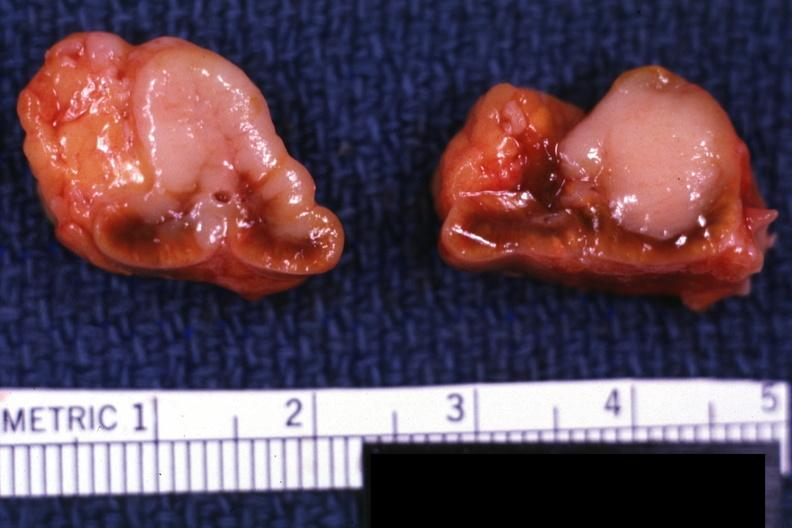does this image show metastatic carcinoma prostate, excellent closeup showing bilateral metastatic lesions primary is slide 6911 and bone metastatsis 6912?
Answer the question using a single word or phrase. Yes 